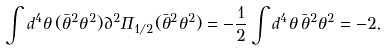Convert formula to latex. <formula><loc_0><loc_0><loc_500><loc_500>\int d ^ { 4 } \theta \, ( \bar { \theta } ^ { 2 } \theta ^ { 2 } ) \partial ^ { 2 } \Pi _ { 1 / 2 } ( \bar { \theta } ^ { 2 } \theta ^ { 2 } ) = - \frac { 1 } { 2 } \int d ^ { 4 } \theta \, \bar { \theta } ^ { 2 } \theta ^ { 2 } = - 2 ,</formula> 